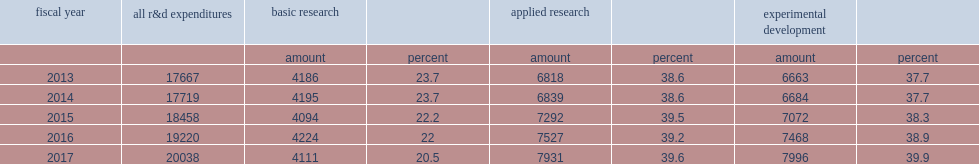In fy 2017, how many percentage points of total ffrdc r&d expenditures did basic research activities account for? 20.5. In fy 2017, basic research activities accounted for 20.5% of total ffrdc r&d expenditures, how many percentage points lower than in fys 2013 and 2014? 3.2. How many percentage points were the remaining r&d expenditures divided in applied research? 39.6. How many percentage points were the remaining r&d expenditures divided in experimental development? 39.9. 